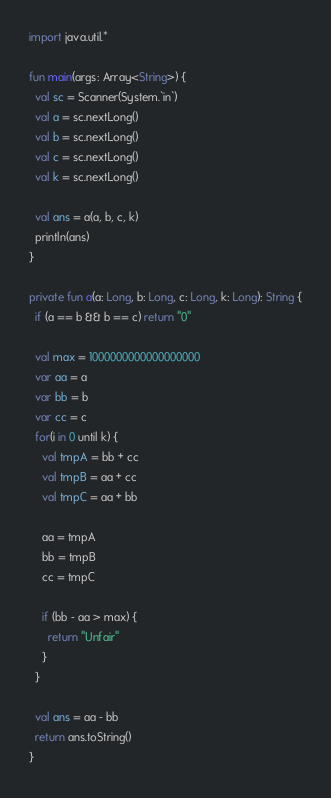Convert code to text. <code><loc_0><loc_0><loc_500><loc_500><_Kotlin_>import java.util.*

fun main(args: Array<String>) {
  val sc = Scanner(System.`in`)
  val a = sc.nextLong()
  val b = sc.nextLong()
  val c = sc.nextLong()
  val k = sc.nextLong()

  val ans = a(a, b, c, k)
  println(ans)
}

private fun a(a: Long, b: Long, c: Long, k: Long): String {
  if (a == b && b == c) return "0"

  val max = 1000000000000000000
  var aa = a
  var bb = b
  var cc = c
  for(i in 0 until k) {
    val tmpA = bb + cc
    val tmpB = aa + cc
    val tmpC = aa + bb

    aa = tmpA
    bb = tmpB
    cc = tmpC

    if (bb - aa > max) {
      return "Unfair"
    }
  }

  val ans = aa - bb
  return ans.toString()
}
</code> 